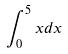<formula> <loc_0><loc_0><loc_500><loc_500>\int _ { 0 } ^ { 5 } x d x</formula> 